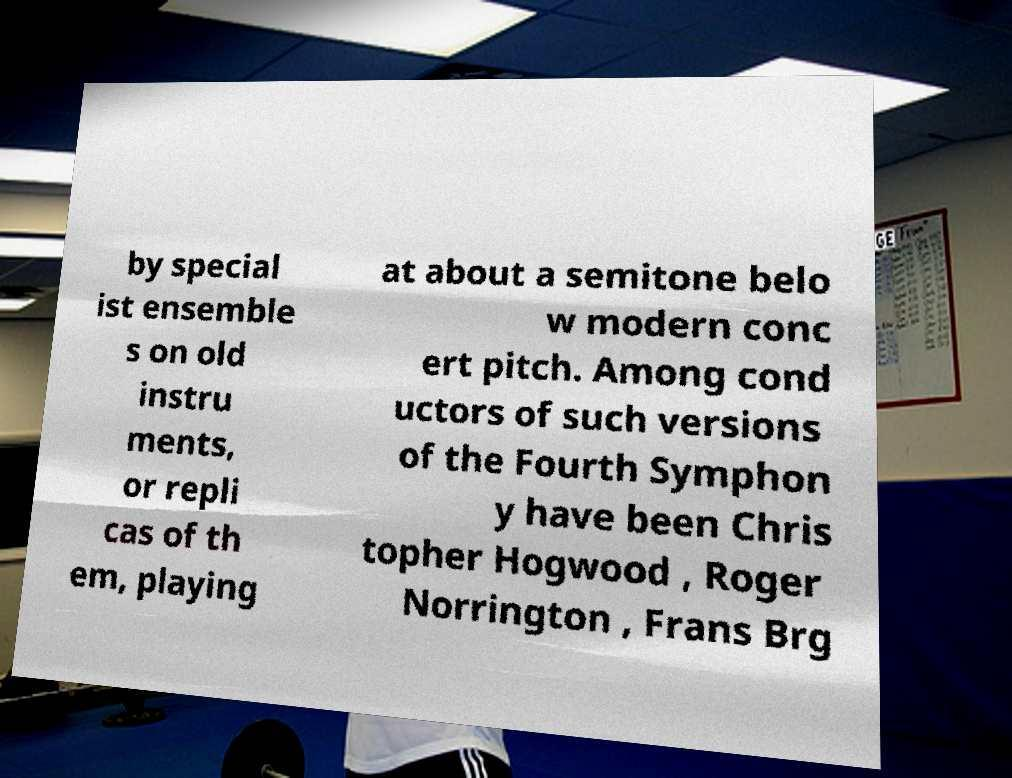Please read and relay the text visible in this image. What does it say? by special ist ensemble s on old instru ments, or repli cas of th em, playing at about a semitone belo w modern conc ert pitch. Among cond uctors of such versions of the Fourth Symphon y have been Chris topher Hogwood , Roger Norrington , Frans Brg 